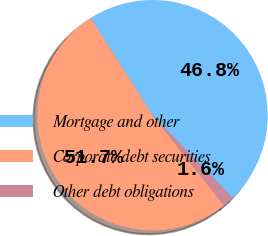<chart> <loc_0><loc_0><loc_500><loc_500><pie_chart><fcel>Mortgage and other<fcel>Corporate debt securities<fcel>Other debt obligations<nl><fcel>46.79%<fcel>51.65%<fcel>1.56%<nl></chart> 